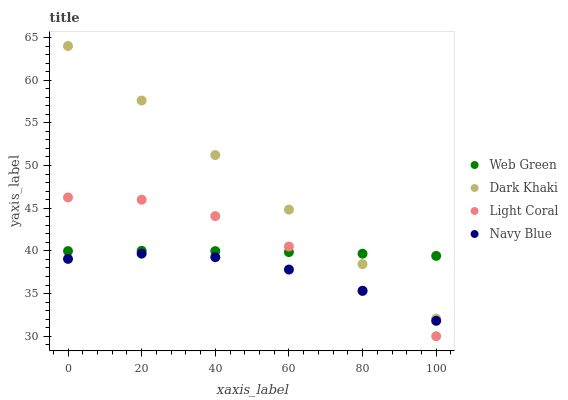Does Navy Blue have the minimum area under the curve?
Answer yes or no. Yes. Does Dark Khaki have the maximum area under the curve?
Answer yes or no. Yes. Does Light Coral have the minimum area under the curve?
Answer yes or no. No. Does Light Coral have the maximum area under the curve?
Answer yes or no. No. Is Dark Khaki the smoothest?
Answer yes or no. Yes. Is Light Coral the roughest?
Answer yes or no. Yes. Is Web Green the smoothest?
Answer yes or no. No. Is Web Green the roughest?
Answer yes or no. No. Does Light Coral have the lowest value?
Answer yes or no. Yes. Does Web Green have the lowest value?
Answer yes or no. No. Does Dark Khaki have the highest value?
Answer yes or no. Yes. Does Light Coral have the highest value?
Answer yes or no. No. Is Navy Blue less than Web Green?
Answer yes or no. Yes. Is Web Green greater than Navy Blue?
Answer yes or no. Yes. Does Web Green intersect Dark Khaki?
Answer yes or no. Yes. Is Web Green less than Dark Khaki?
Answer yes or no. No. Is Web Green greater than Dark Khaki?
Answer yes or no. No. Does Navy Blue intersect Web Green?
Answer yes or no. No. 